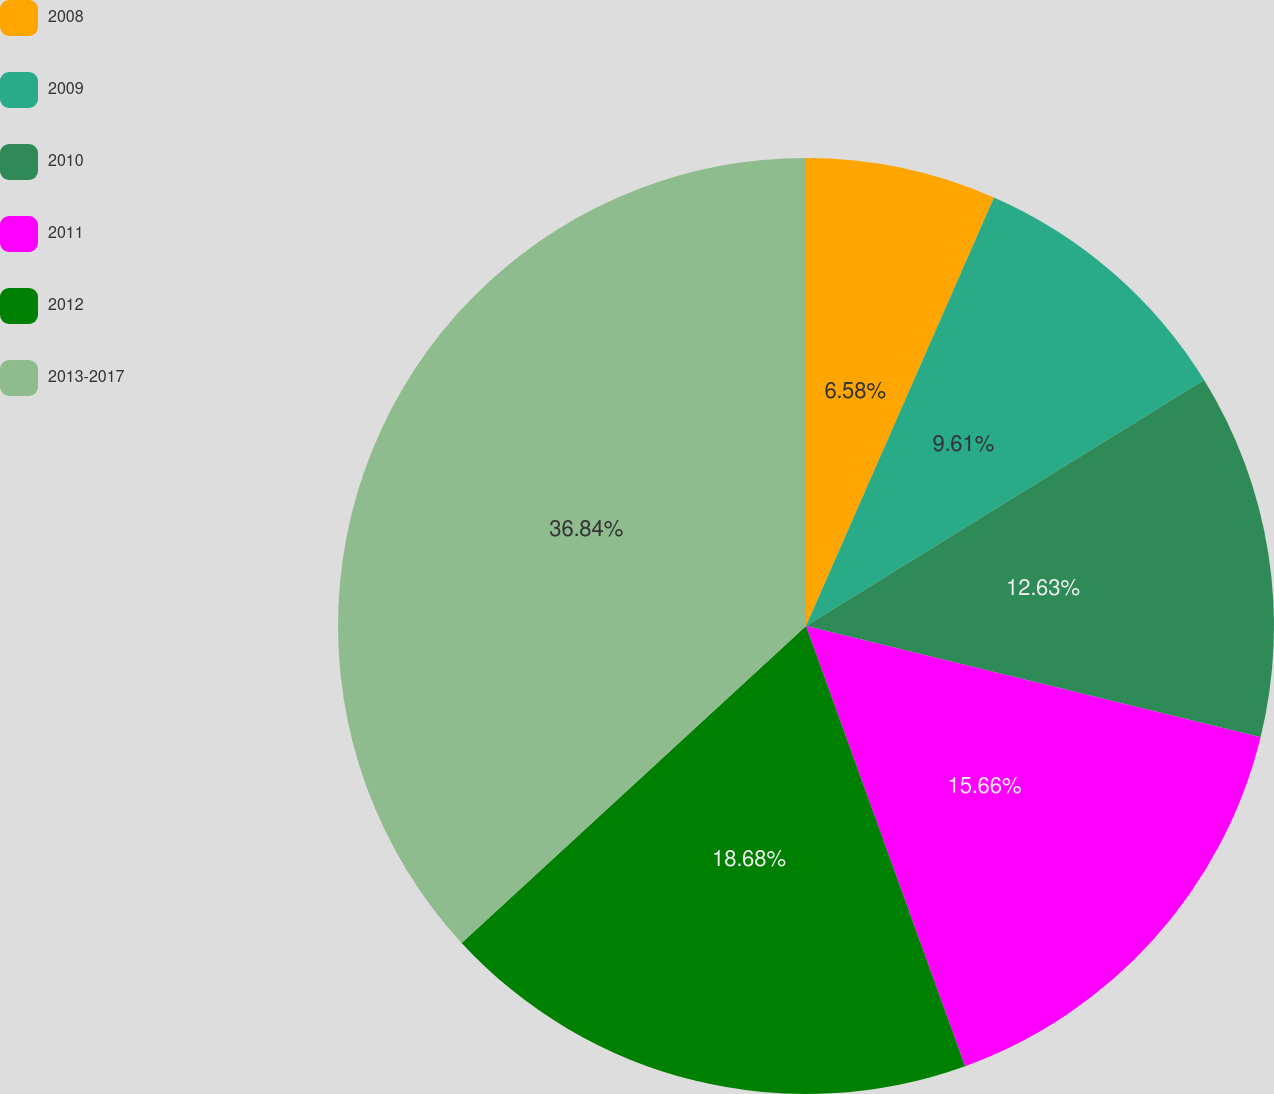<chart> <loc_0><loc_0><loc_500><loc_500><pie_chart><fcel>2008<fcel>2009<fcel>2010<fcel>2011<fcel>2012<fcel>2013-2017<nl><fcel>6.58%<fcel>9.61%<fcel>12.63%<fcel>15.66%<fcel>18.68%<fcel>36.84%<nl></chart> 